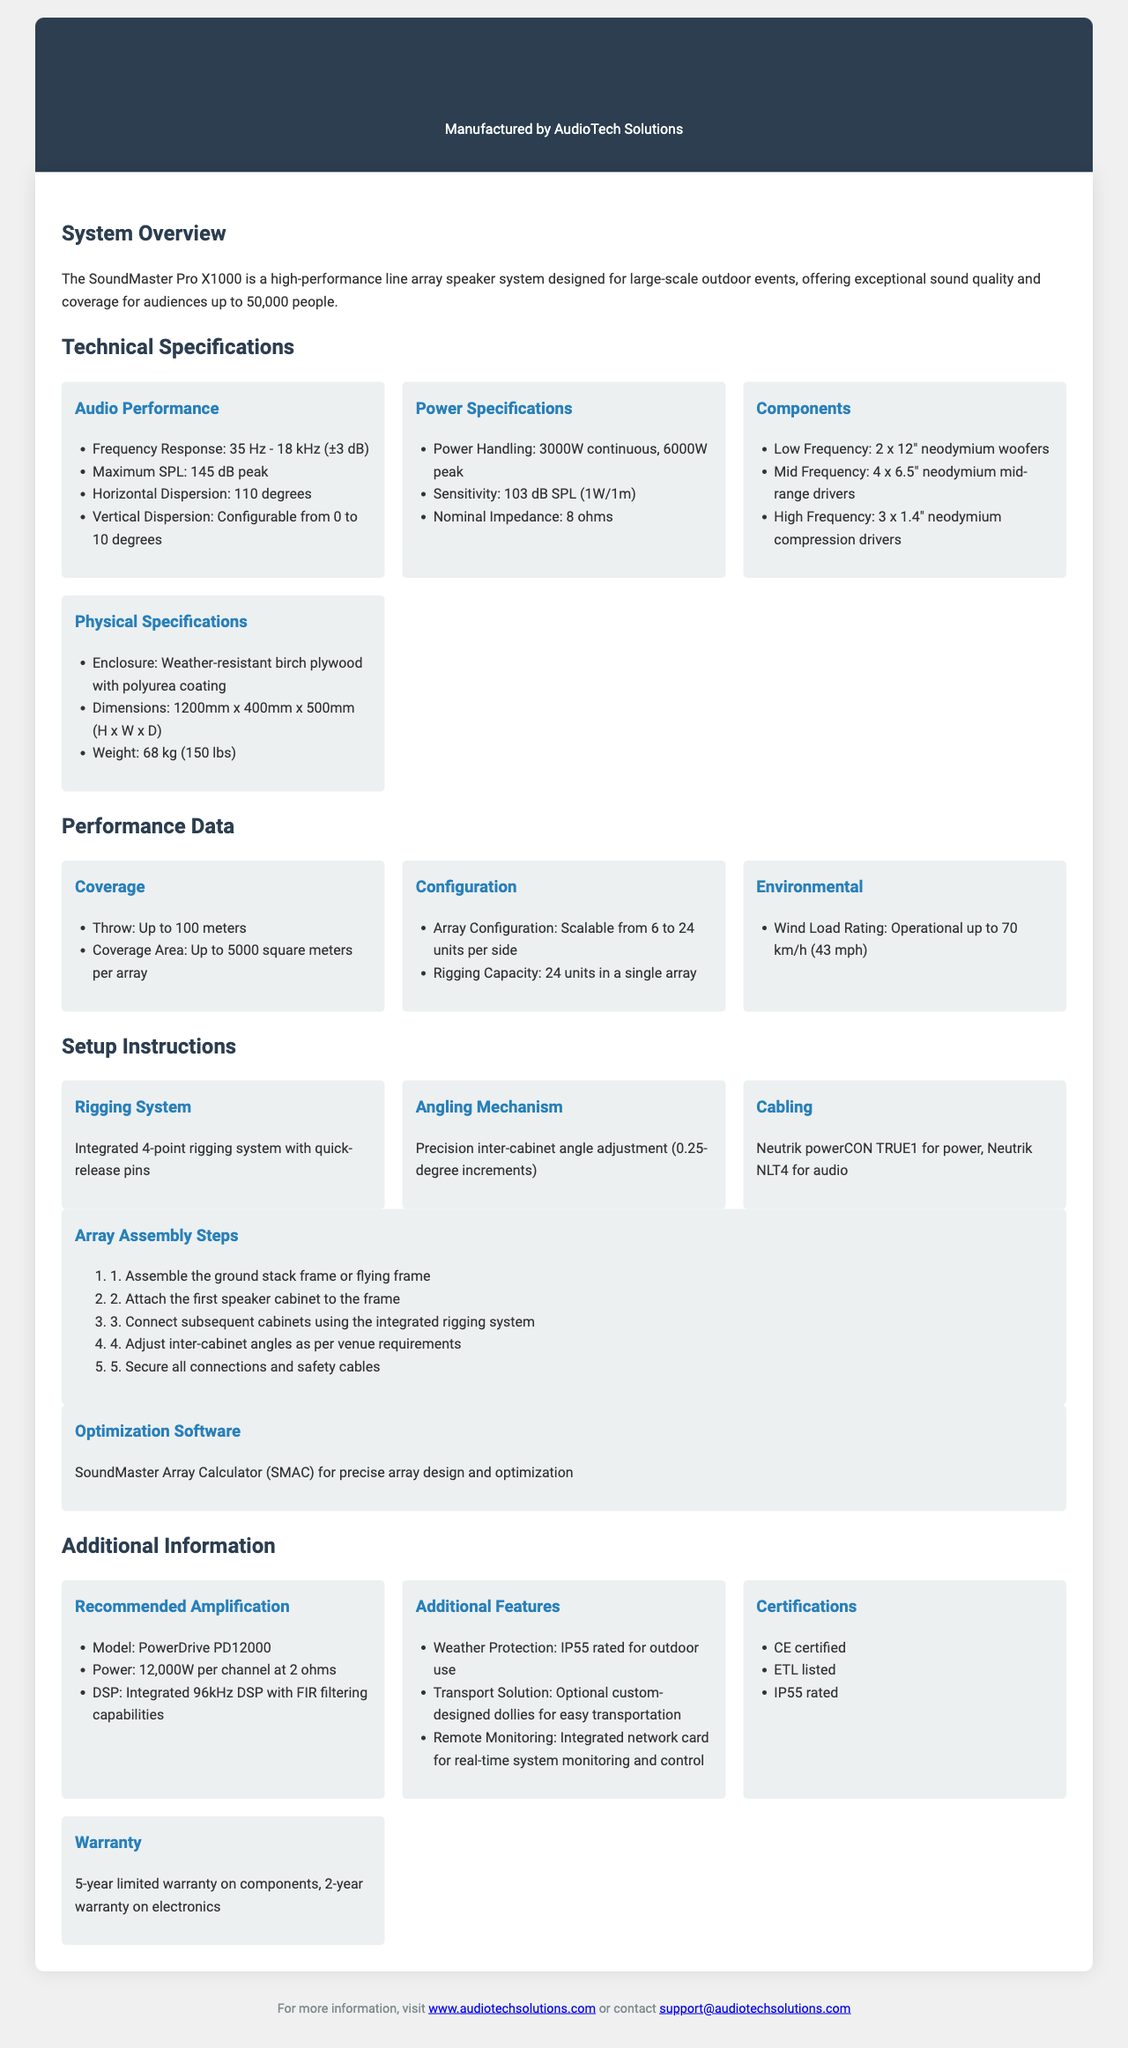What is the frequency response of the speaker system? The frequency response of the SoundMaster Pro X1000 is provided in the technical specifications section.
Answer: 35 Hz - 18 kHz (±3 dB) What is the maximum sound pressure level of the system? The maximum SPL is listed under technical specifications as part of the audio performance metrics.
Answer: 145 dB peak What is the weight of the SoundMaster Pro X1000? The weight is specified in the physical specifications part of the technical specifications section.
Answer: 68 kg (150 lbs) How many units can be rigged in a single array? The rigging capacity value is mentioned in the performance data section.
Answer: 24 units What type of protection rating does the product have for outdoor use? The additional features section includes details about weather protection.
Answer: IP55 rated What software is recommended for array optimization? The optimization software is listed in the setup instructions section of the document.
Answer: SoundMaster Array Calculator (SMAC) What is the recommended amplifier model for the system? The recommended amplification section clearly states the amplifier model to be used with the speaker system.
Answer: PowerDrive PD12000 How are the inter-cabinet angles adjusted during setup? The angling mechanism is described in the setup instructions and highlights how adjustments can be made.
Answer: 0.25-degree increments 